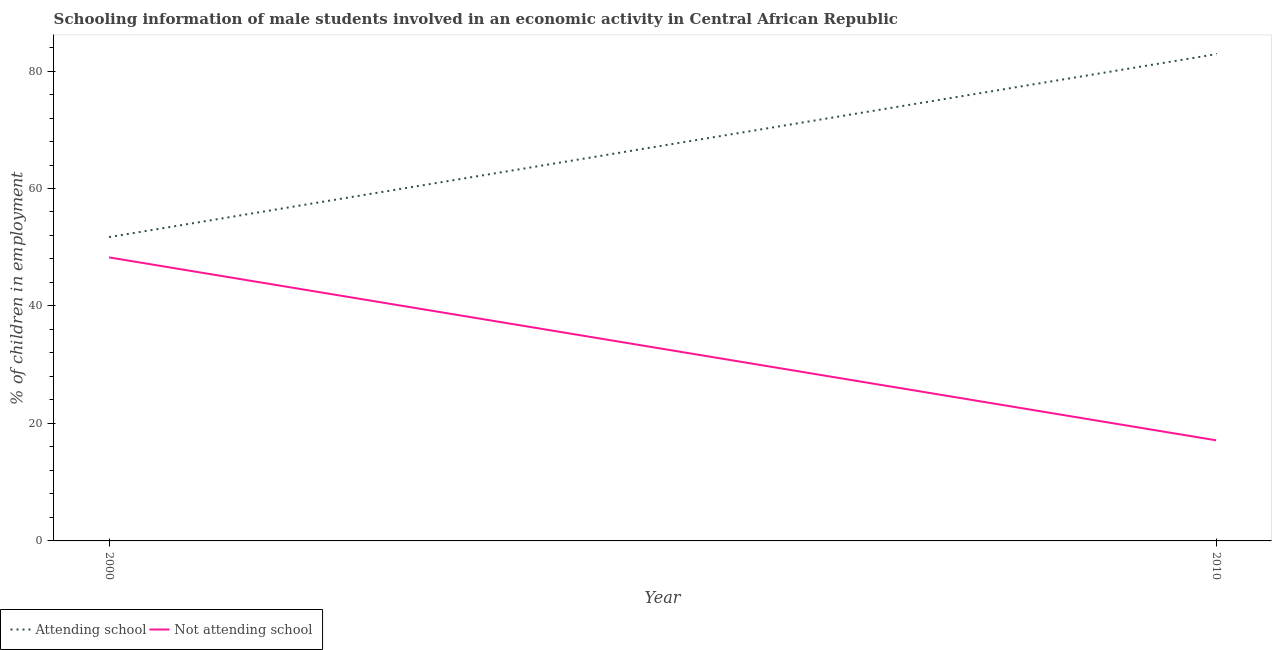What is the percentage of employed males who are not attending school in 2000?
Provide a succinct answer. 48.27. Across all years, what is the maximum percentage of employed males who are attending school?
Offer a very short reply. 82.87. Across all years, what is the minimum percentage of employed males who are not attending school?
Make the answer very short. 17.13. In which year was the percentage of employed males who are attending school maximum?
Offer a very short reply. 2010. What is the total percentage of employed males who are attending school in the graph?
Keep it short and to the point. 134.6. What is the difference between the percentage of employed males who are attending school in 2000 and that in 2010?
Your answer should be very brief. -31.14. What is the difference between the percentage of employed males who are attending school in 2010 and the percentage of employed males who are not attending school in 2000?
Ensure brevity in your answer.  34.6. What is the average percentage of employed males who are not attending school per year?
Provide a short and direct response. 32.7. In the year 2000, what is the difference between the percentage of employed males who are attending school and percentage of employed males who are not attending school?
Offer a terse response. 3.46. In how many years, is the percentage of employed males who are not attending school greater than 36 %?
Give a very brief answer. 1. What is the ratio of the percentage of employed males who are attending school in 2000 to that in 2010?
Provide a short and direct response. 0.62. Is the percentage of employed males who are attending school in 2000 less than that in 2010?
Your answer should be very brief. Yes. Does the percentage of employed males who are attending school monotonically increase over the years?
Your answer should be very brief. Yes. How many lines are there?
Make the answer very short. 2. Are the values on the major ticks of Y-axis written in scientific E-notation?
Provide a short and direct response. No. Does the graph contain grids?
Give a very brief answer. No. Where does the legend appear in the graph?
Ensure brevity in your answer.  Bottom left. What is the title of the graph?
Provide a succinct answer. Schooling information of male students involved in an economic activity in Central African Republic. What is the label or title of the X-axis?
Your answer should be compact. Year. What is the label or title of the Y-axis?
Your response must be concise. % of children in employment. What is the % of children in employment in Attending school in 2000?
Offer a terse response. 51.73. What is the % of children in employment of Not attending school in 2000?
Your answer should be compact. 48.27. What is the % of children in employment in Attending school in 2010?
Provide a short and direct response. 82.87. What is the % of children in employment of Not attending school in 2010?
Provide a succinct answer. 17.13. Across all years, what is the maximum % of children in employment in Attending school?
Make the answer very short. 82.87. Across all years, what is the maximum % of children in employment of Not attending school?
Your answer should be compact. 48.27. Across all years, what is the minimum % of children in employment in Attending school?
Make the answer very short. 51.73. Across all years, what is the minimum % of children in employment of Not attending school?
Provide a succinct answer. 17.13. What is the total % of children in employment in Attending school in the graph?
Give a very brief answer. 134.6. What is the total % of children in employment in Not attending school in the graph?
Keep it short and to the point. 65.4. What is the difference between the % of children in employment of Attending school in 2000 and that in 2010?
Your answer should be very brief. -31.14. What is the difference between the % of children in employment of Not attending school in 2000 and that in 2010?
Offer a very short reply. 31.14. What is the difference between the % of children in employment in Attending school in 2000 and the % of children in employment in Not attending school in 2010?
Give a very brief answer. 34.6. What is the average % of children in employment of Attending school per year?
Give a very brief answer. 67.3. What is the average % of children in employment in Not attending school per year?
Provide a succinct answer. 32.7. In the year 2000, what is the difference between the % of children in employment in Attending school and % of children in employment in Not attending school?
Ensure brevity in your answer.  3.46. In the year 2010, what is the difference between the % of children in employment of Attending school and % of children in employment of Not attending school?
Your answer should be compact. 65.74. What is the ratio of the % of children in employment of Attending school in 2000 to that in 2010?
Offer a terse response. 0.62. What is the ratio of the % of children in employment in Not attending school in 2000 to that in 2010?
Provide a succinct answer. 2.82. What is the difference between the highest and the second highest % of children in employment of Attending school?
Offer a very short reply. 31.14. What is the difference between the highest and the second highest % of children in employment in Not attending school?
Your response must be concise. 31.14. What is the difference between the highest and the lowest % of children in employment of Attending school?
Provide a succinct answer. 31.14. What is the difference between the highest and the lowest % of children in employment in Not attending school?
Your answer should be very brief. 31.14. 